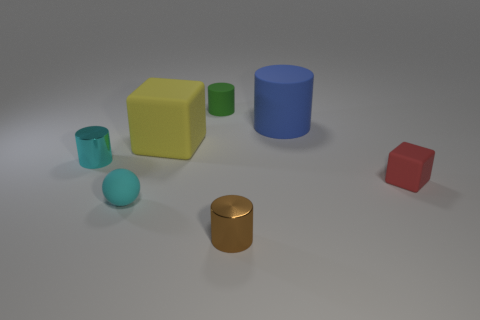Can you describe the size relationships between the objects? Certainly! The objects vary in size, with the blue cylinder being the tallest and the red cube appearing to be the shortest. The yellow and green cubes are medium-sized, and the metallic cylinder and the teal sphere are the smallest items in view. 